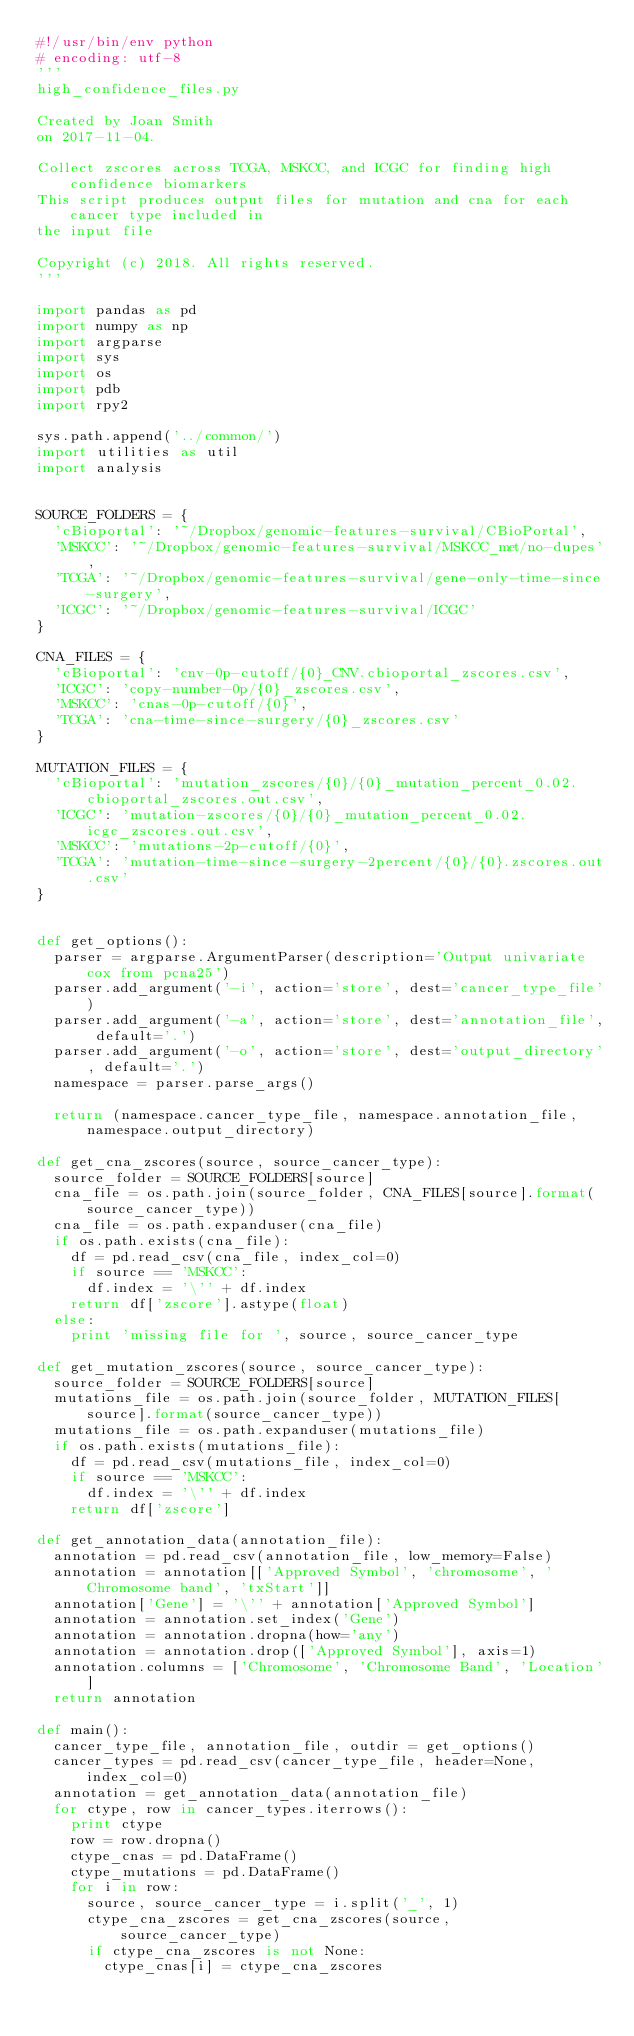Convert code to text. <code><loc_0><loc_0><loc_500><loc_500><_Python_>#!/usr/bin/env python
# encoding: utf-8
'''
high_confidence_files.py

Created by Joan Smith
on 2017-11-04.

Collect zscores across TCGA, MSKCC, and ICGC for finding high confidence biomarkers
This script produces output files for mutation and cna for each cancer type included in
the input file

Copyright (c) 2018. All rights reserved.
'''

import pandas as pd
import numpy as np
import argparse
import sys
import os
import pdb
import rpy2

sys.path.append('../common/')
import utilities as util
import analysis


SOURCE_FOLDERS = {
  'cBioportal': '~/Dropbox/genomic-features-survival/CBioPortal',
  'MSKCC': '~/Dropbox/genomic-features-survival/MSKCC_met/no-dupes',
  'TCGA': '~/Dropbox/genomic-features-survival/gene-only-time-since-surgery',
  'ICGC': '~/Dropbox/genomic-features-survival/ICGC'
}

CNA_FILES = {
  'cBioportal': 'cnv-0p-cutoff/{0}_CNV.cbioportal_zscores.csv',
  'ICGC': 'copy-number-0p/{0}_zscores.csv',
  'MSKCC': 'cnas-0p-cutoff/{0}',
  'TCGA': 'cna-time-since-surgery/{0}_zscores.csv'
}

MUTATION_FILES = {
  'cBioportal': 'mutation_zscores/{0}/{0}_mutation_percent_0.02.cbioportal_zscores.out.csv',
  'ICGC': 'mutation-zscores/{0}/{0}_mutation_percent_0.02.icgc_zscores.out.csv',
  'MSKCC': 'mutations-2p-cutoff/{0}',
  'TCGA': 'mutation-time-since-surgery-2percent/{0}/{0}.zscores.out.csv'
}


def get_options():
  parser = argparse.ArgumentParser(description='Output univariate cox from pcna25')
  parser.add_argument('-i', action='store', dest='cancer_type_file')
  parser.add_argument('-a', action='store', dest='annotation_file', default='.')
  parser.add_argument('-o', action='store', dest='output_directory', default='.')
  namespace = parser.parse_args()

  return (namespace.cancer_type_file, namespace.annotation_file, namespace.output_directory)

def get_cna_zscores(source, source_cancer_type):
  source_folder = SOURCE_FOLDERS[source]
  cna_file = os.path.join(source_folder, CNA_FILES[source].format(source_cancer_type))
  cna_file = os.path.expanduser(cna_file)
  if os.path.exists(cna_file):
    df = pd.read_csv(cna_file, index_col=0)
    if source == 'MSKCC':
      df.index = '\'' + df.index
    return df['zscore'].astype(float)
  else:
    print 'missing file for ', source, source_cancer_type

def get_mutation_zscores(source, source_cancer_type):
  source_folder = SOURCE_FOLDERS[source]
  mutations_file = os.path.join(source_folder, MUTATION_FILES[source].format(source_cancer_type))
  mutations_file = os.path.expanduser(mutations_file)
  if os.path.exists(mutations_file):
    df = pd.read_csv(mutations_file, index_col=0)
    if source == 'MSKCC':
      df.index = '\'' + df.index
    return df['zscore']

def get_annotation_data(annotation_file):
  annotation = pd.read_csv(annotation_file, low_memory=False)
  annotation = annotation[['Approved Symbol', 'chromosome', 'Chromosome band', 'txStart']]
  annotation['Gene'] = '\'' + annotation['Approved Symbol']
  annotation = annotation.set_index('Gene')
  annotation = annotation.dropna(how='any')
  annotation = annotation.drop(['Approved Symbol'], axis=1)
  annotation.columns = ['Chromosome', 'Chromosome Band', 'Location']
  return annotation

def main():
  cancer_type_file, annotation_file, outdir = get_options()
  cancer_types = pd.read_csv(cancer_type_file, header=None, index_col=0)
  annotation = get_annotation_data(annotation_file)
  for ctype, row in cancer_types.iterrows():
    print ctype
    row = row.dropna()
    ctype_cnas = pd.DataFrame()
    ctype_mutations = pd.DataFrame()
    for i in row:
      source, source_cancer_type = i.split('_', 1)
      ctype_cna_zscores = get_cna_zscores(source, source_cancer_type)
      if ctype_cna_zscores is not None:
        ctype_cnas[i] = ctype_cna_zscores
</code> 